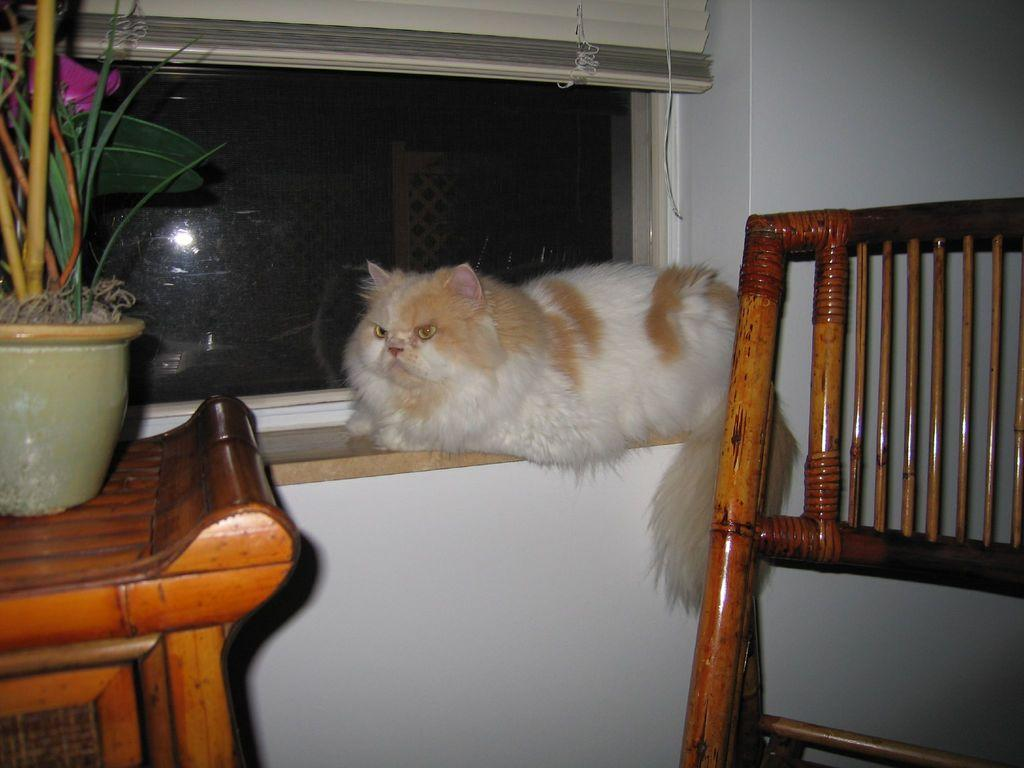What type of animal can be seen in the image? There is a cat in the image. Where is the cat located in the image? The cat is sitting on a window. What is the setting of the image? The window is in a room. What furniture is present in the room? There is a chair and a table in the room. What is placed on the table? A flower pot is placed on the table. What can be seen in the background of the image? There is a window and a wall visible in the background. What book is the cat reading in the image? There is no book present in the image, and the cat is not reading. 